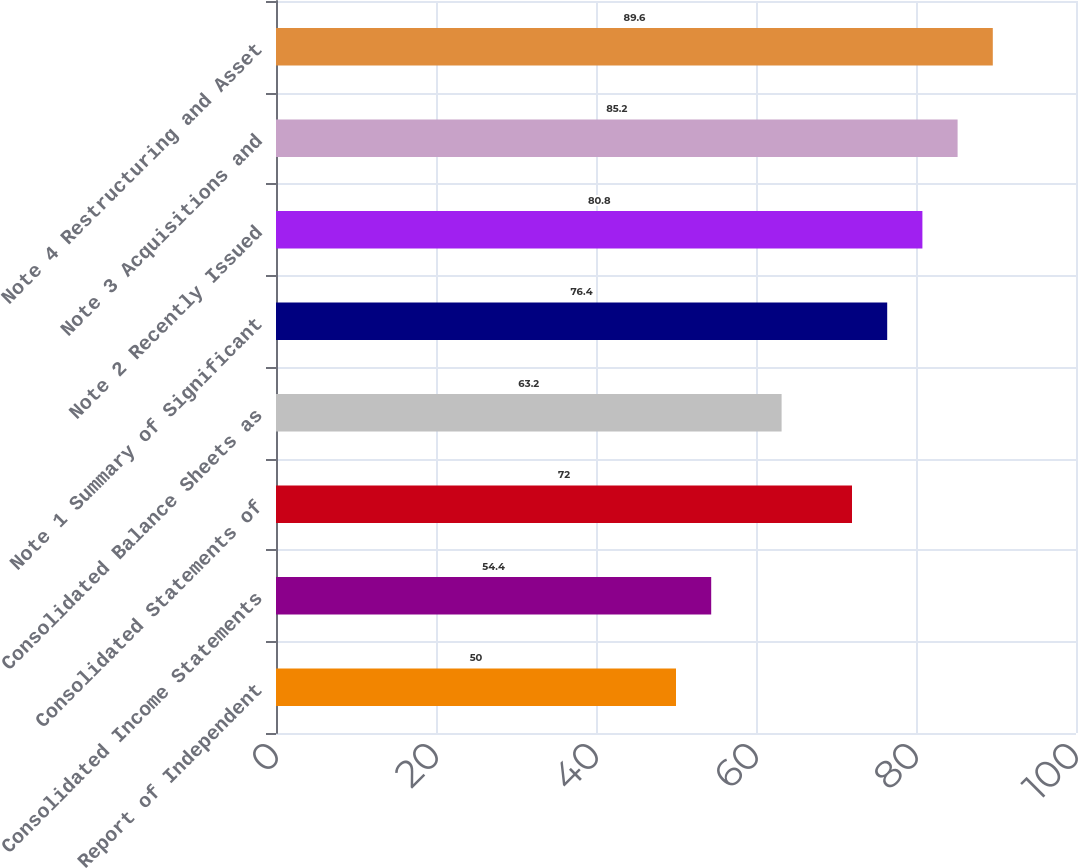Convert chart to OTSL. <chart><loc_0><loc_0><loc_500><loc_500><bar_chart><fcel>Report of Independent<fcel>Consolidated Income Statements<fcel>Consolidated Statements of<fcel>Consolidated Balance Sheets as<fcel>Note 1 Summary of Significant<fcel>Note 2 Recently Issued<fcel>Note 3 Acquisitions and<fcel>Note 4 Restructuring and Asset<nl><fcel>50<fcel>54.4<fcel>72<fcel>63.2<fcel>76.4<fcel>80.8<fcel>85.2<fcel>89.6<nl></chart> 